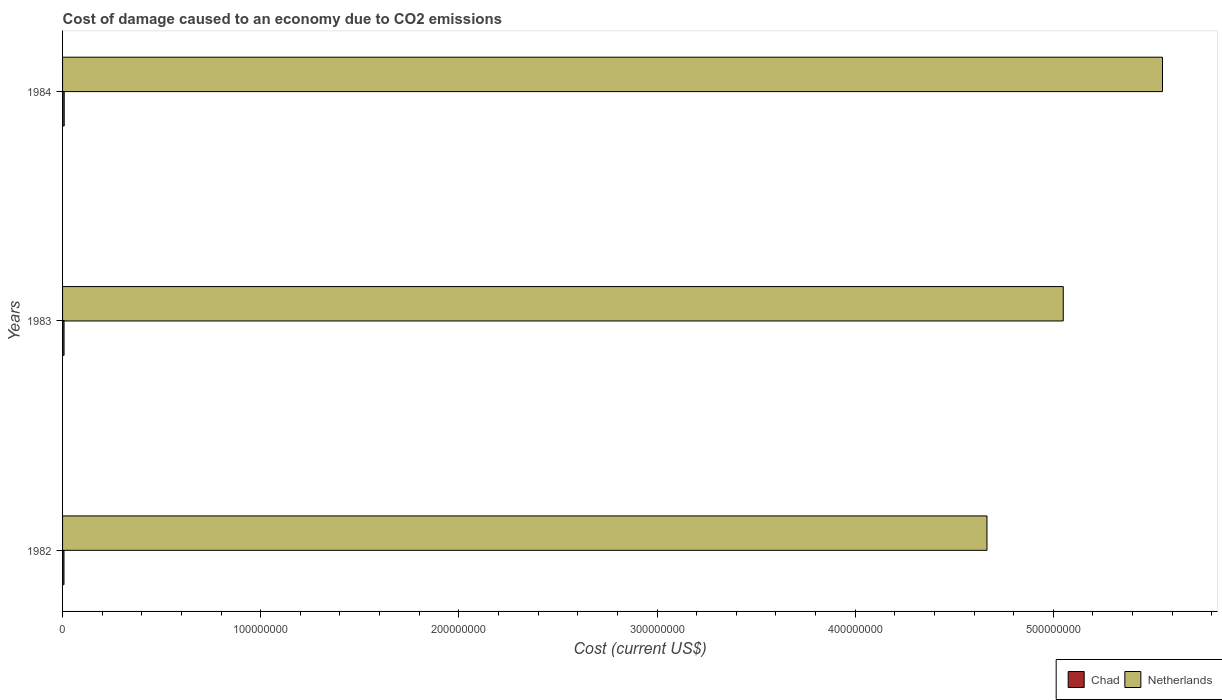Are the number of bars per tick equal to the number of legend labels?
Provide a succinct answer. Yes. What is the label of the 3rd group of bars from the top?
Give a very brief answer. 1982. In how many cases, is the number of bars for a given year not equal to the number of legend labels?
Make the answer very short. 0. What is the cost of damage caused due to CO2 emissisons in Chad in 1982?
Offer a terse response. 7.13e+05. Across all years, what is the maximum cost of damage caused due to CO2 emissisons in Chad?
Your answer should be very brief. 8.28e+05. Across all years, what is the minimum cost of damage caused due to CO2 emissisons in Chad?
Provide a succinct answer. 7.13e+05. In which year was the cost of damage caused due to CO2 emissisons in Chad maximum?
Provide a short and direct response. 1984. In which year was the cost of damage caused due to CO2 emissisons in Netherlands minimum?
Your answer should be compact. 1982. What is the total cost of damage caused due to CO2 emissisons in Chad in the graph?
Offer a terse response. 2.29e+06. What is the difference between the cost of damage caused due to CO2 emissisons in Chad in 1982 and that in 1983?
Your response must be concise. -3.69e+04. What is the difference between the cost of damage caused due to CO2 emissisons in Netherlands in 1983 and the cost of damage caused due to CO2 emissisons in Chad in 1982?
Provide a succinct answer. 5.04e+08. What is the average cost of damage caused due to CO2 emissisons in Chad per year?
Your answer should be compact. 7.64e+05. In the year 1982, what is the difference between the cost of damage caused due to CO2 emissisons in Netherlands and cost of damage caused due to CO2 emissisons in Chad?
Provide a succinct answer. 4.66e+08. What is the ratio of the cost of damage caused due to CO2 emissisons in Netherlands in 1983 to that in 1984?
Offer a very short reply. 0.91. Is the cost of damage caused due to CO2 emissisons in Chad in 1982 less than that in 1984?
Offer a very short reply. Yes. What is the difference between the highest and the second highest cost of damage caused due to CO2 emissisons in Netherlands?
Make the answer very short. 5.01e+07. What is the difference between the highest and the lowest cost of damage caused due to CO2 emissisons in Netherlands?
Make the answer very short. 8.86e+07. In how many years, is the cost of damage caused due to CO2 emissisons in Chad greater than the average cost of damage caused due to CO2 emissisons in Chad taken over all years?
Provide a short and direct response. 1. Is the sum of the cost of damage caused due to CO2 emissisons in Netherlands in 1982 and 1983 greater than the maximum cost of damage caused due to CO2 emissisons in Chad across all years?
Ensure brevity in your answer.  Yes. What does the 1st bar from the top in 1984 represents?
Offer a very short reply. Netherlands. What does the 2nd bar from the bottom in 1983 represents?
Provide a short and direct response. Netherlands. Are all the bars in the graph horizontal?
Your response must be concise. Yes. How many years are there in the graph?
Your response must be concise. 3. Does the graph contain any zero values?
Make the answer very short. No. How many legend labels are there?
Your answer should be very brief. 2. How are the legend labels stacked?
Offer a very short reply. Horizontal. What is the title of the graph?
Give a very brief answer. Cost of damage caused to an economy due to CO2 emissions. Does "Zambia" appear as one of the legend labels in the graph?
Provide a short and direct response. No. What is the label or title of the X-axis?
Your answer should be very brief. Cost (current US$). What is the Cost (current US$) in Chad in 1982?
Ensure brevity in your answer.  7.13e+05. What is the Cost (current US$) in Netherlands in 1982?
Your response must be concise. 4.67e+08. What is the Cost (current US$) of Chad in 1983?
Your answer should be very brief. 7.50e+05. What is the Cost (current US$) in Netherlands in 1983?
Provide a short and direct response. 5.05e+08. What is the Cost (current US$) in Chad in 1984?
Make the answer very short. 8.28e+05. What is the Cost (current US$) in Netherlands in 1984?
Offer a very short reply. 5.55e+08. Across all years, what is the maximum Cost (current US$) of Chad?
Your answer should be very brief. 8.28e+05. Across all years, what is the maximum Cost (current US$) of Netherlands?
Provide a succinct answer. 5.55e+08. Across all years, what is the minimum Cost (current US$) in Chad?
Provide a short and direct response. 7.13e+05. Across all years, what is the minimum Cost (current US$) of Netherlands?
Your answer should be compact. 4.67e+08. What is the total Cost (current US$) in Chad in the graph?
Provide a short and direct response. 2.29e+06. What is the total Cost (current US$) in Netherlands in the graph?
Give a very brief answer. 1.53e+09. What is the difference between the Cost (current US$) in Chad in 1982 and that in 1983?
Make the answer very short. -3.69e+04. What is the difference between the Cost (current US$) in Netherlands in 1982 and that in 1983?
Keep it short and to the point. -3.85e+07. What is the difference between the Cost (current US$) in Chad in 1982 and that in 1984?
Ensure brevity in your answer.  -1.15e+05. What is the difference between the Cost (current US$) in Netherlands in 1982 and that in 1984?
Your response must be concise. -8.86e+07. What is the difference between the Cost (current US$) in Chad in 1983 and that in 1984?
Keep it short and to the point. -7.78e+04. What is the difference between the Cost (current US$) in Netherlands in 1983 and that in 1984?
Keep it short and to the point. -5.01e+07. What is the difference between the Cost (current US$) in Chad in 1982 and the Cost (current US$) in Netherlands in 1983?
Offer a terse response. -5.04e+08. What is the difference between the Cost (current US$) in Chad in 1982 and the Cost (current US$) in Netherlands in 1984?
Provide a succinct answer. -5.54e+08. What is the difference between the Cost (current US$) of Chad in 1983 and the Cost (current US$) of Netherlands in 1984?
Offer a very short reply. -5.54e+08. What is the average Cost (current US$) in Chad per year?
Make the answer very short. 7.64e+05. What is the average Cost (current US$) of Netherlands per year?
Give a very brief answer. 5.09e+08. In the year 1982, what is the difference between the Cost (current US$) in Chad and Cost (current US$) in Netherlands?
Keep it short and to the point. -4.66e+08. In the year 1983, what is the difference between the Cost (current US$) in Chad and Cost (current US$) in Netherlands?
Provide a succinct answer. -5.04e+08. In the year 1984, what is the difference between the Cost (current US$) in Chad and Cost (current US$) in Netherlands?
Ensure brevity in your answer.  -5.54e+08. What is the ratio of the Cost (current US$) in Chad in 1982 to that in 1983?
Keep it short and to the point. 0.95. What is the ratio of the Cost (current US$) in Netherlands in 1982 to that in 1983?
Keep it short and to the point. 0.92. What is the ratio of the Cost (current US$) of Chad in 1982 to that in 1984?
Your response must be concise. 0.86. What is the ratio of the Cost (current US$) in Netherlands in 1982 to that in 1984?
Your response must be concise. 0.84. What is the ratio of the Cost (current US$) in Chad in 1983 to that in 1984?
Keep it short and to the point. 0.91. What is the ratio of the Cost (current US$) in Netherlands in 1983 to that in 1984?
Provide a short and direct response. 0.91. What is the difference between the highest and the second highest Cost (current US$) in Chad?
Ensure brevity in your answer.  7.78e+04. What is the difference between the highest and the second highest Cost (current US$) of Netherlands?
Your answer should be compact. 5.01e+07. What is the difference between the highest and the lowest Cost (current US$) in Chad?
Ensure brevity in your answer.  1.15e+05. What is the difference between the highest and the lowest Cost (current US$) in Netherlands?
Provide a succinct answer. 8.86e+07. 